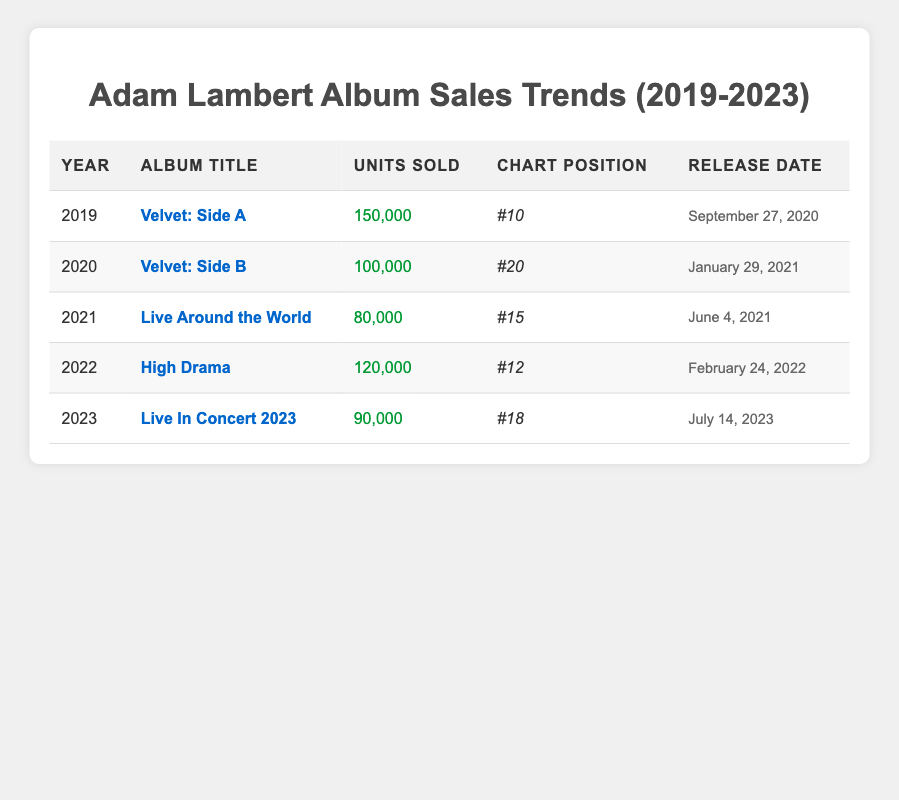What was the highest album sales figure recorded in the past five years? The table shows sales for each album listed. The highest figure is for "Velvet: Side A" in 2019 with units sold at 150,000.
Answer: 150,000 Which album achieved the highest chart position? Among the albums listed, "Velvet: Side A" in 2019 reached the highest chart position at #10.
Answer: Velvet: Side A How many total units were sold across all albums from 2019 to 2023? To find the total units sold, we sum up the units from each year: 150,000 + 100,000 + 80,000 + 120,000 + 90,000 = 540,000.
Answer: 540,000 In which year did Adam Lambert sell the least number of albums? By examining the units sold, "Live Around the World" in 2021 has the lowest sales recorded at 80,000 units.
Answer: 2021 Is it true that every album released over the past five years sold more than 70,000 units? Checking the units sold for each album, all albums sold more than 70,000 units (80,000 being the lowest). Therefore, the statement is true.
Answer: Yes What was the average number of units sold per album released in this period? There are five albums and their total sales are 540,000. Dividing this total by the number of albums (540,000 / 5) gives an average of 108,000.
Answer: 108,000 Did the album "High Drama" outperform "Live Around the World" in both sales and chart position? "High Drama" sold 120,000 units and reached position #12, while "Live Around the World" achieved 80,000 units but a better chart position at #15. Thus, "High Drama" outperformed "Live Around the World" in sales but not in chart position.
Answer: No What is the trend of album sales from 2019 to 2023? Observing the sales data, there is a variation in units sold: 150,000 (2019), 100,000 (2020), 80,000 (2021), 120,000 (2022), and 90,000 (2023). The trend does not show consistent growth or decline; it fluctuates with ups and downs.
Answer: Fluctuating Which album had the longest gap between release date and the year in the table? "Velvet: Side A" was released on September 27, 2020, but its sales are recorded for 2019, which indicates a discrepancy. The longest gap is clearly illustrated since it sold ahead of its release, showcasing its early popularity.
Answer: Velvet: Side A 